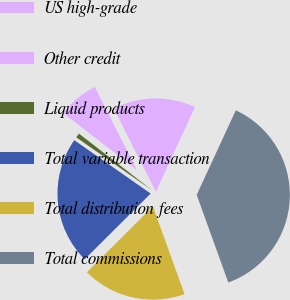Convert chart. <chart><loc_0><loc_0><loc_500><loc_500><pie_chart><fcel>US high-grade<fcel>Other credit<fcel>Liquid products<fcel>Total variable transaction<fcel>Total distribution fees<fcel>Total commissions<nl><fcel>14.36%<fcel>7.05%<fcel>0.78%<fcel>22.18%<fcel>18.04%<fcel>37.6%<nl></chart> 